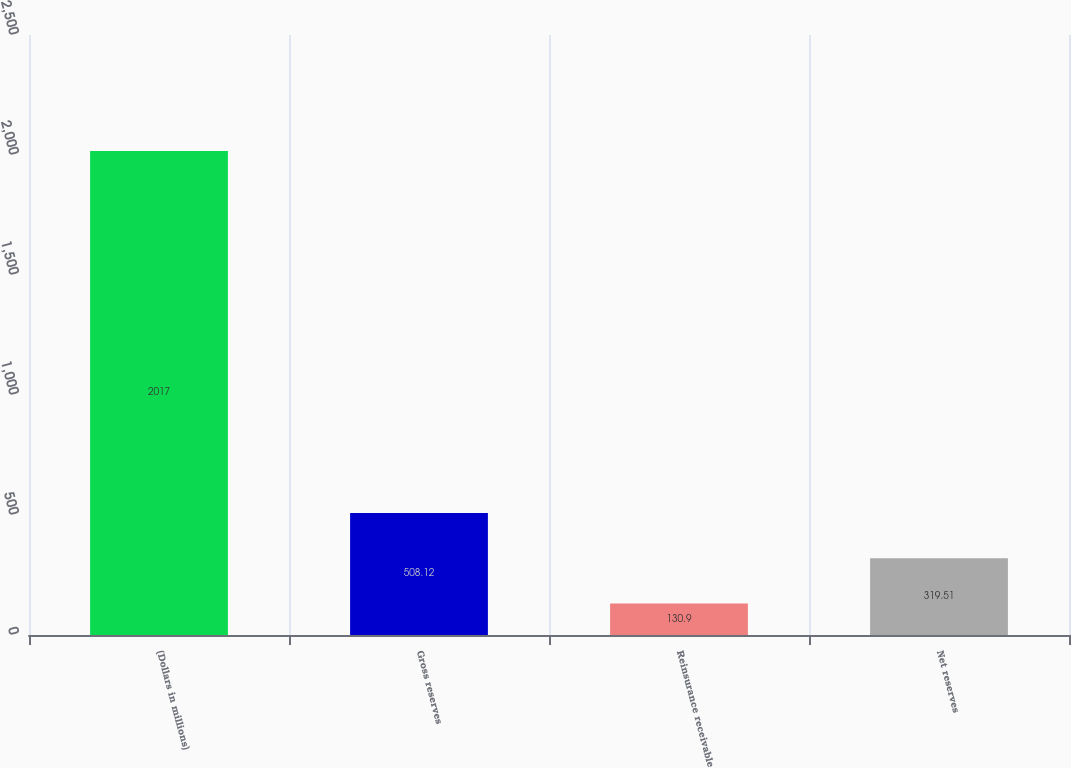Convert chart. <chart><loc_0><loc_0><loc_500><loc_500><bar_chart><fcel>(Dollars in millions)<fcel>Gross reserves<fcel>Reinsurance receivable<fcel>Net reserves<nl><fcel>2017<fcel>508.12<fcel>130.9<fcel>319.51<nl></chart> 